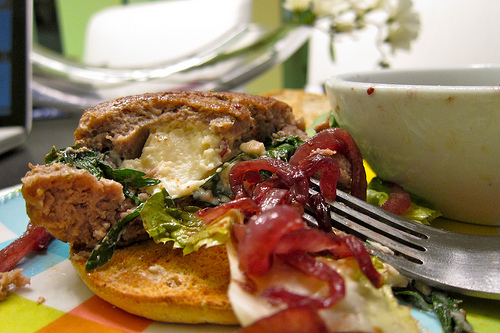<image>
Is there a fork in the bowl? No. The fork is not contained within the bowl. These objects have a different spatial relationship. 